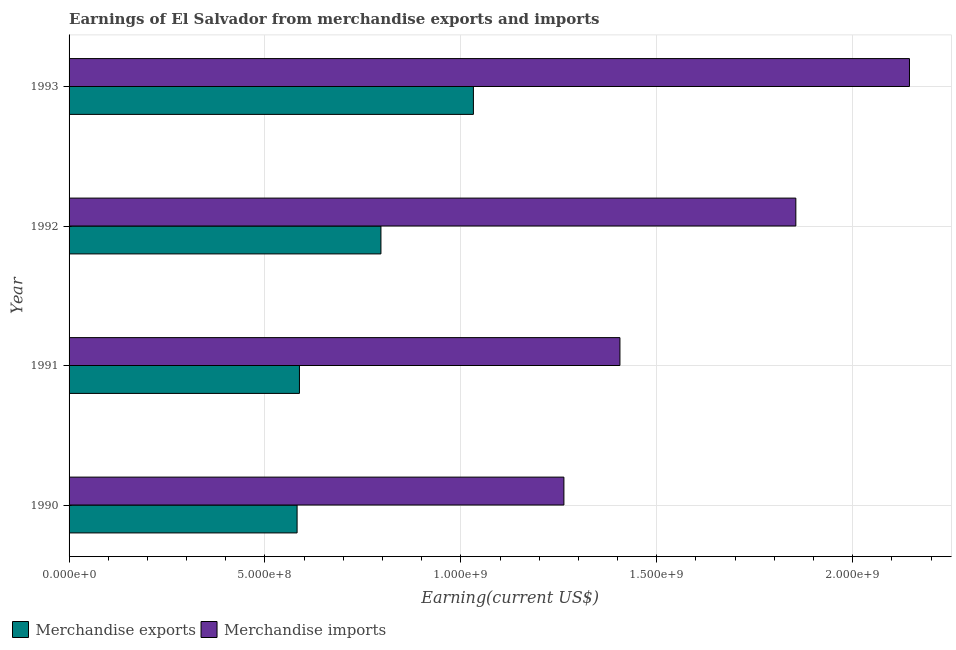Are the number of bars per tick equal to the number of legend labels?
Provide a short and direct response. Yes. How many bars are there on the 1st tick from the top?
Provide a short and direct response. 2. How many bars are there on the 4th tick from the bottom?
Provide a short and direct response. 2. What is the label of the 3rd group of bars from the top?
Your answer should be very brief. 1991. What is the earnings from merchandise imports in 1992?
Offer a very short reply. 1.86e+09. Across all years, what is the maximum earnings from merchandise exports?
Ensure brevity in your answer.  1.03e+09. Across all years, what is the minimum earnings from merchandise imports?
Keep it short and to the point. 1.26e+09. In which year was the earnings from merchandise exports maximum?
Give a very brief answer. 1993. In which year was the earnings from merchandise exports minimum?
Offer a terse response. 1990. What is the total earnings from merchandise imports in the graph?
Offer a very short reply. 6.67e+09. What is the difference between the earnings from merchandise imports in 1991 and that in 1992?
Provide a short and direct response. -4.49e+08. What is the difference between the earnings from merchandise exports in 1990 and the earnings from merchandise imports in 1992?
Your answer should be very brief. -1.27e+09. What is the average earnings from merchandise exports per year?
Keep it short and to the point. 7.50e+08. In the year 1991, what is the difference between the earnings from merchandise imports and earnings from merchandise exports?
Offer a terse response. 8.18e+08. In how many years, is the earnings from merchandise imports greater than 100000000 US$?
Offer a very short reply. 4. What is the ratio of the earnings from merchandise exports in 1991 to that in 1993?
Provide a succinct answer. 0.57. Is the earnings from merchandise exports in 1991 less than that in 1992?
Keep it short and to the point. Yes. What is the difference between the highest and the second highest earnings from merchandise imports?
Give a very brief answer. 2.90e+08. What is the difference between the highest and the lowest earnings from merchandise imports?
Your answer should be very brief. 8.82e+08. In how many years, is the earnings from merchandise imports greater than the average earnings from merchandise imports taken over all years?
Offer a terse response. 2. Is the sum of the earnings from merchandise exports in 1990 and 1993 greater than the maximum earnings from merchandise imports across all years?
Offer a terse response. No. What does the 2nd bar from the top in 1993 represents?
Offer a terse response. Merchandise exports. How many bars are there?
Offer a very short reply. 8. Are all the bars in the graph horizontal?
Make the answer very short. Yes. How many years are there in the graph?
Give a very brief answer. 4. What is the difference between two consecutive major ticks on the X-axis?
Provide a short and direct response. 5.00e+08. Are the values on the major ticks of X-axis written in scientific E-notation?
Make the answer very short. Yes. Does the graph contain grids?
Keep it short and to the point. Yes. How many legend labels are there?
Your answer should be very brief. 2. How are the legend labels stacked?
Offer a very short reply. Horizontal. What is the title of the graph?
Your answer should be very brief. Earnings of El Salvador from merchandise exports and imports. What is the label or title of the X-axis?
Give a very brief answer. Earning(current US$). What is the Earning(current US$) of Merchandise exports in 1990?
Ensure brevity in your answer.  5.82e+08. What is the Earning(current US$) of Merchandise imports in 1990?
Your answer should be compact. 1.26e+09. What is the Earning(current US$) of Merchandise exports in 1991?
Your answer should be very brief. 5.88e+08. What is the Earning(current US$) in Merchandise imports in 1991?
Your answer should be compact. 1.41e+09. What is the Earning(current US$) in Merchandise exports in 1992?
Your answer should be compact. 7.96e+08. What is the Earning(current US$) in Merchandise imports in 1992?
Ensure brevity in your answer.  1.86e+09. What is the Earning(current US$) in Merchandise exports in 1993?
Offer a very short reply. 1.03e+09. What is the Earning(current US$) of Merchandise imports in 1993?
Provide a succinct answer. 2.14e+09. Across all years, what is the maximum Earning(current US$) in Merchandise exports?
Give a very brief answer. 1.03e+09. Across all years, what is the maximum Earning(current US$) in Merchandise imports?
Give a very brief answer. 2.14e+09. Across all years, what is the minimum Earning(current US$) of Merchandise exports?
Keep it short and to the point. 5.82e+08. Across all years, what is the minimum Earning(current US$) of Merchandise imports?
Keep it short and to the point. 1.26e+09. What is the total Earning(current US$) of Merchandise exports in the graph?
Your response must be concise. 3.00e+09. What is the total Earning(current US$) of Merchandise imports in the graph?
Your answer should be very brief. 6.67e+09. What is the difference between the Earning(current US$) in Merchandise exports in 1990 and that in 1991?
Your answer should be very brief. -6.00e+06. What is the difference between the Earning(current US$) in Merchandise imports in 1990 and that in 1991?
Your answer should be very brief. -1.43e+08. What is the difference between the Earning(current US$) of Merchandise exports in 1990 and that in 1992?
Give a very brief answer. -2.14e+08. What is the difference between the Earning(current US$) in Merchandise imports in 1990 and that in 1992?
Ensure brevity in your answer.  -5.92e+08. What is the difference between the Earning(current US$) of Merchandise exports in 1990 and that in 1993?
Give a very brief answer. -4.50e+08. What is the difference between the Earning(current US$) of Merchandise imports in 1990 and that in 1993?
Offer a terse response. -8.82e+08. What is the difference between the Earning(current US$) in Merchandise exports in 1991 and that in 1992?
Offer a terse response. -2.08e+08. What is the difference between the Earning(current US$) of Merchandise imports in 1991 and that in 1992?
Ensure brevity in your answer.  -4.49e+08. What is the difference between the Earning(current US$) in Merchandise exports in 1991 and that in 1993?
Offer a very short reply. -4.44e+08. What is the difference between the Earning(current US$) of Merchandise imports in 1991 and that in 1993?
Offer a very short reply. -7.39e+08. What is the difference between the Earning(current US$) in Merchandise exports in 1992 and that in 1993?
Keep it short and to the point. -2.36e+08. What is the difference between the Earning(current US$) of Merchandise imports in 1992 and that in 1993?
Your answer should be compact. -2.90e+08. What is the difference between the Earning(current US$) in Merchandise exports in 1990 and the Earning(current US$) in Merchandise imports in 1991?
Provide a succinct answer. -8.24e+08. What is the difference between the Earning(current US$) in Merchandise exports in 1990 and the Earning(current US$) in Merchandise imports in 1992?
Your answer should be compact. -1.27e+09. What is the difference between the Earning(current US$) of Merchandise exports in 1990 and the Earning(current US$) of Merchandise imports in 1993?
Your answer should be compact. -1.56e+09. What is the difference between the Earning(current US$) in Merchandise exports in 1991 and the Earning(current US$) in Merchandise imports in 1992?
Provide a short and direct response. -1.27e+09. What is the difference between the Earning(current US$) in Merchandise exports in 1991 and the Earning(current US$) in Merchandise imports in 1993?
Provide a succinct answer. -1.56e+09. What is the difference between the Earning(current US$) in Merchandise exports in 1992 and the Earning(current US$) in Merchandise imports in 1993?
Your response must be concise. -1.35e+09. What is the average Earning(current US$) in Merchandise exports per year?
Your response must be concise. 7.50e+08. What is the average Earning(current US$) of Merchandise imports per year?
Offer a terse response. 1.67e+09. In the year 1990, what is the difference between the Earning(current US$) in Merchandise exports and Earning(current US$) in Merchandise imports?
Provide a succinct answer. -6.81e+08. In the year 1991, what is the difference between the Earning(current US$) of Merchandise exports and Earning(current US$) of Merchandise imports?
Offer a very short reply. -8.18e+08. In the year 1992, what is the difference between the Earning(current US$) in Merchandise exports and Earning(current US$) in Merchandise imports?
Your answer should be compact. -1.06e+09. In the year 1993, what is the difference between the Earning(current US$) in Merchandise exports and Earning(current US$) in Merchandise imports?
Give a very brief answer. -1.11e+09. What is the ratio of the Earning(current US$) of Merchandise imports in 1990 to that in 1991?
Your response must be concise. 0.9. What is the ratio of the Earning(current US$) in Merchandise exports in 1990 to that in 1992?
Provide a short and direct response. 0.73. What is the ratio of the Earning(current US$) in Merchandise imports in 1990 to that in 1992?
Your response must be concise. 0.68. What is the ratio of the Earning(current US$) of Merchandise exports in 1990 to that in 1993?
Your answer should be very brief. 0.56. What is the ratio of the Earning(current US$) in Merchandise imports in 1990 to that in 1993?
Keep it short and to the point. 0.59. What is the ratio of the Earning(current US$) of Merchandise exports in 1991 to that in 1992?
Provide a succinct answer. 0.74. What is the ratio of the Earning(current US$) in Merchandise imports in 1991 to that in 1992?
Provide a short and direct response. 0.76. What is the ratio of the Earning(current US$) in Merchandise exports in 1991 to that in 1993?
Provide a short and direct response. 0.57. What is the ratio of the Earning(current US$) in Merchandise imports in 1991 to that in 1993?
Your answer should be very brief. 0.66. What is the ratio of the Earning(current US$) of Merchandise exports in 1992 to that in 1993?
Your response must be concise. 0.77. What is the ratio of the Earning(current US$) of Merchandise imports in 1992 to that in 1993?
Your response must be concise. 0.86. What is the difference between the highest and the second highest Earning(current US$) of Merchandise exports?
Provide a succinct answer. 2.36e+08. What is the difference between the highest and the second highest Earning(current US$) of Merchandise imports?
Your response must be concise. 2.90e+08. What is the difference between the highest and the lowest Earning(current US$) in Merchandise exports?
Make the answer very short. 4.50e+08. What is the difference between the highest and the lowest Earning(current US$) of Merchandise imports?
Your answer should be very brief. 8.82e+08. 